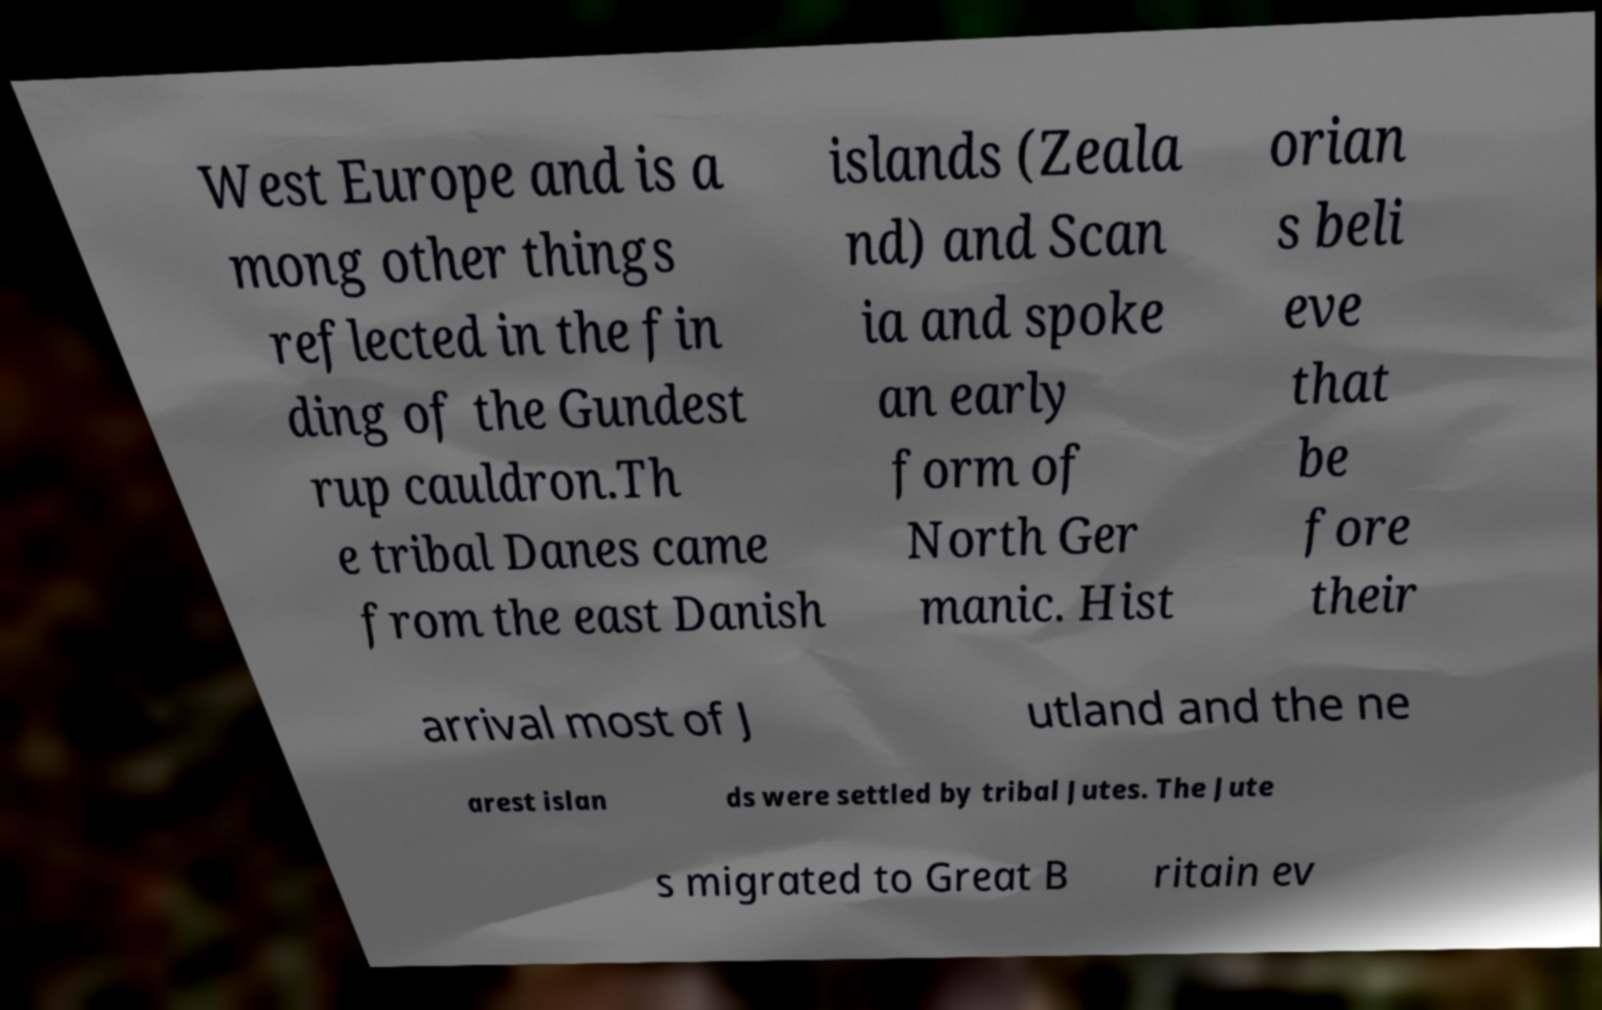There's text embedded in this image that I need extracted. Can you transcribe it verbatim? West Europe and is a mong other things reflected in the fin ding of the Gundest rup cauldron.Th e tribal Danes came from the east Danish islands (Zeala nd) and Scan ia and spoke an early form of North Ger manic. Hist orian s beli eve that be fore their arrival most of J utland and the ne arest islan ds were settled by tribal Jutes. The Jute s migrated to Great B ritain ev 